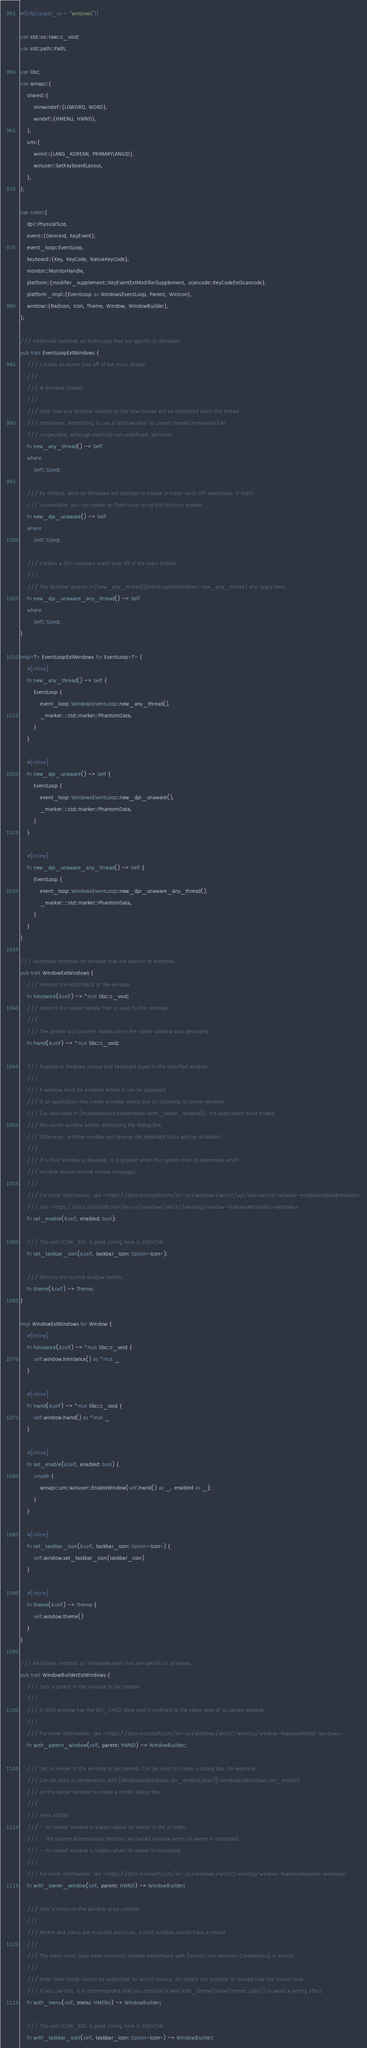<code> <loc_0><loc_0><loc_500><loc_500><_Rust_>#![cfg(target_os = "windows")]

use std::os::raw::c_void;
use std::path::Path;

use libc;
use winapi::{
    shared::{
        minwindef::{LOWORD, WORD},
        windef::{HMENU, HWND},
    },
    um::{
        winnt::{LANG_KOREAN, PRIMARYLANGID},
        winuser::GetKeyboardLayout,
    },
};

use crate::{
    dpi::PhysicalSize,
    event::{DeviceId, KeyEvent},
    event_loop::EventLoop,
    keyboard::{Key, KeyCode, NativeKeyCode},
    monitor::MonitorHandle,
    platform::{modifier_supplement::KeyEventExtModifierSupplement, scancode::KeyCodeExtScancode},
    platform_impl::{EventLoop as WindowsEventLoop, Parent, WinIcon},
    window::{BadIcon, Icon, Theme, Window, WindowBuilder},
};

/// Additional methods on `EventLoop` that are specific to Windows.
pub trait EventLoopExtWindows {
    /// Creates an event loop off of the main thread.
    ///
    /// # `Window` caveats
    ///
    /// Note that any `Window` created on the new thread will be destroyed when the thread
    /// terminates. Attempting to use a `Window` after its parent thread terminates has
    /// unspecified, although explicitly not undefined, behavior.
    fn new_any_thread() -> Self
    where
        Self: Sized;

    /// By default, winit on Windows will attempt to enable process-wide DPI awareness. If that's
    /// undesirable, you can create an `EventLoop` using this function instead.
    fn new_dpi_unaware() -> Self
    where
        Self: Sized;

    /// Creates a DPI-unaware event loop off of the main thread.
    ///
    /// The `Window` caveats in [`new_any_thread`](EventLoopExtWindows::new_any_thread) also apply here.
    fn new_dpi_unaware_any_thread() -> Self
    where
        Self: Sized;
}

impl<T> EventLoopExtWindows for EventLoop<T> {
    #[inline]
    fn new_any_thread() -> Self {
        EventLoop {
            event_loop: WindowsEventLoop::new_any_thread(),
            _marker: ::std::marker::PhantomData,
        }
    }

    #[inline]
    fn new_dpi_unaware() -> Self {
        EventLoop {
            event_loop: WindowsEventLoop::new_dpi_unaware(),
            _marker: ::std::marker::PhantomData,
        }
    }

    #[inline]
    fn new_dpi_unaware_any_thread() -> Self {
        EventLoop {
            event_loop: WindowsEventLoop::new_dpi_unaware_any_thread(),
            _marker: ::std::marker::PhantomData,
        }
    }
}

/// Additional methods on `Window` that are specific to Windows.
pub trait WindowExtWindows {
    /// Returns the HINSTANCE of the window
    fn hinstance(&self) -> *mut libc::c_void;
    /// Returns the native handle that is used by this window.
    ///
    /// The pointer will become invalid when the native window was destroyed.
    fn hwnd(&self) -> *mut libc::c_void;

    /// Enables or disables mouse and keyboard input to the specified window.
    ///
    /// A window must be enabled before it can be activated.
    /// If an application has create a modal dialog box by disabling its owner window
    /// (as described in [`WindowBuilderExtWindows::with_owner_window`]), the application must enable
    /// the owner window before destroying the dialog box.
    /// Otherwise, another window will receive the keyboard focus and be activated.
    ///
    /// If a child window is disabled, it is ignored when the system tries to determine which
    /// window should receive mouse messages.
    ///
    /// For more information, see <https://docs.microsoft.com/en-us/windows/win32/api/winuser/nf-winuser-enablewindow#remarks>
    /// and <https://docs.microsoft.com/en-us/windows/win32/winmsg/window-features#disabled-windows>
    fn set_enable(&self, enabled: bool);

    /// This sets `ICON_BIG`. A good ceiling here is 256x256.
    fn set_taskbar_icon(&self, taskbar_icon: Option<Icon>);

    /// Returns the current window theme.
    fn theme(&self) -> Theme;
}

impl WindowExtWindows for Window {
    #[inline]
    fn hinstance(&self) -> *mut libc::c_void {
        self.window.hinstance() as *mut _
    }

    #[inline]
    fn hwnd(&self) -> *mut libc::c_void {
        self.window.hwnd() as *mut _
    }

    #[inline]
    fn set_enable(&self, enabled: bool) {
        unsafe {
            winapi::um::winuser::EnableWindow(self.hwnd() as _, enabled as _);
        }
    }

    #[inline]
    fn set_taskbar_icon(&self, taskbar_icon: Option<Icon>) {
        self.window.set_taskbar_icon(taskbar_icon)
    }

    #[inline]
    fn theme(&self) -> Theme {
        self.window.theme()
    }
}

/// Additional methods on `WindowBuilder` that are specific to Windows.
pub trait WindowBuilderExtWindows {
    /// Sets a parent to the window to be created.
    ///
    /// A child window has the WS_CHILD style and is confined to the client area of its parent window.
    ///
    /// For more information, see <https://docs.microsoft.com/en-us/windows/win32/winmsg/window-features#child-windows>
    fn with_parent_window(self, parent: HWND) -> WindowBuilder;

    /// Set an owner to the window to be created. Can be used to create a dialog box, for example.
    /// Can be used in combination with [`WindowExtWindows::set_enable(false)`](WindowExtWindows::set_enable)
    /// on the owner window to create a modal dialog box.
    ///
    /// From MSDN:
    /// - An owned window is always above its owner in the z-order.
    /// - The system automatically destroys an owned window when its owner is destroyed.
    /// - An owned window is hidden when its owner is minimized.
    ///
    /// For more information, see <https://docs.microsoft.com/en-us/windows/win32/winmsg/window-features#owned-windows>
    fn with_owner_window(self, parent: HWND) -> WindowBuilder;

    /// Sets a menu on the window to be created.
    ///
    /// Parent and menu are mutually exclusive; a child window cannot have a menu!
    ///
    /// The menu must have been manually created beforehand with [`winapi::um::winuser::CreateMenu`] or similar.
    ///
    /// Note: Dark mode cannot be supported for win32 menus, it's simply not possible to change how the menus look.
    /// If you use this, it is recommended that you combine it with `with_theme(Some(Theme::Light))` to avoid a jarring effect.
    fn with_menu(self, menu: HMENU) -> WindowBuilder;

    /// This sets `ICON_BIG`. A good ceiling here is 256x256.
    fn with_taskbar_icon(self, taskbar_icon: Option<Icon>) -> WindowBuilder;
</code> 